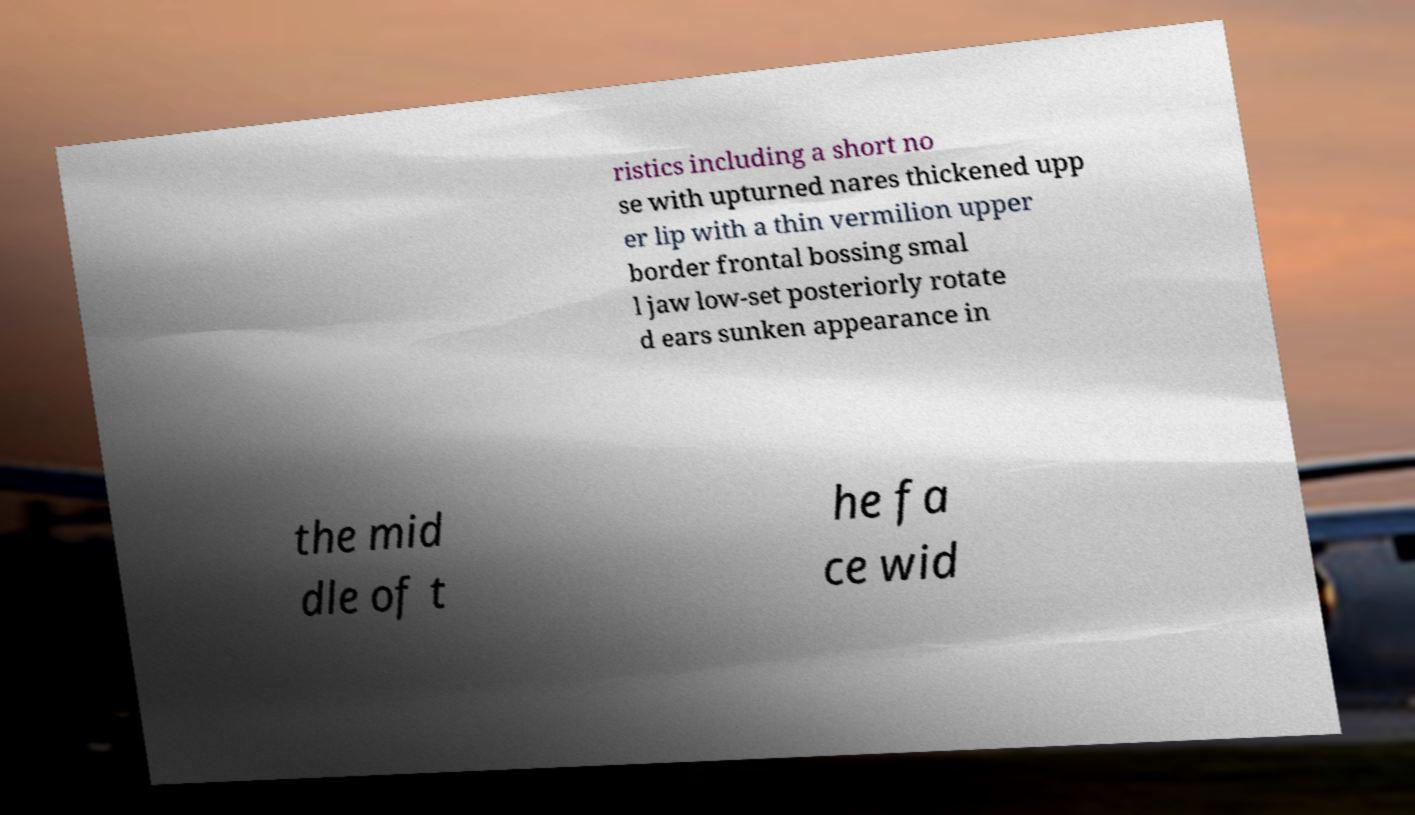Could you extract and type out the text from this image? ristics including a short no se with upturned nares thickened upp er lip with a thin vermilion upper border frontal bossing smal l jaw low-set posteriorly rotate d ears sunken appearance in the mid dle of t he fa ce wid 